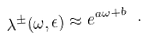<formula> <loc_0><loc_0><loc_500><loc_500>\lambda ^ { \pm } ( \omega , \epsilon ) \approx e ^ { a \omega + b } \ .</formula> 